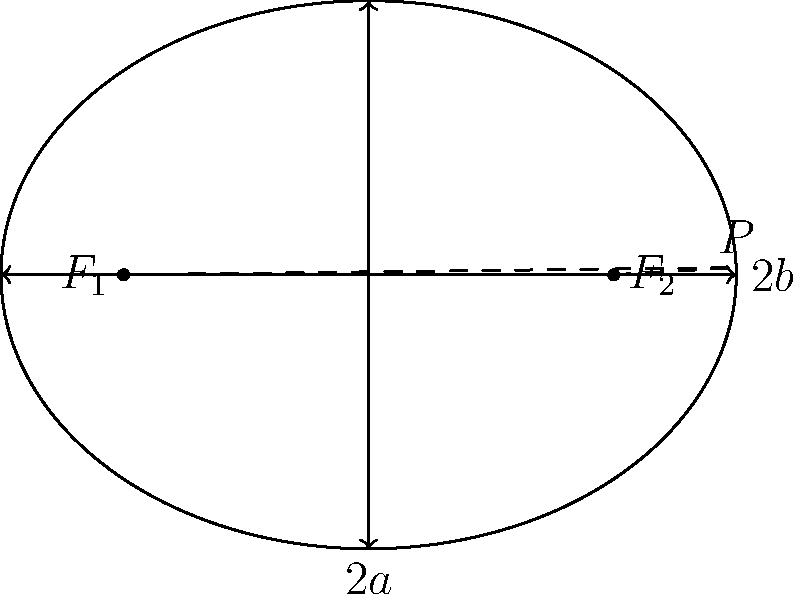Given an ellipse with focal points $F_1$ and $F_2$, and a point $P$ on the ellipse, prove that the sum of the distances from $P$ to the two focal points is constant and equal to the major axis length. How does this property relate to the eccentricity of the ellipse, and what implications does it have for potential applications in fields such as optics or satellite orbits? 1. Definition of an ellipse: The set of points $P$ such that $PF_1 + PF_2 = 2a$, where $2a$ is the length of the major axis.

2. Proof:
   a. Let $c$ be the distance from the center to each focus.
   b. The equation of the ellipse in Cartesian coordinates is:
      $$\frac{x^2}{a^2} + \frac{y^2}{b^2} = 1$$
      where $b^2 = a^2 - c^2$

3. For any point $P(x,y)$ on the ellipse:
   $$PF_1 + PF_2 = \sqrt{(x+c)^2 + y^2} + \sqrt{(x-c)^2 + y^2}$$

4. Using the algebraic properties of the ellipse equation and the distance formula, we can prove that this sum always equals $2a$.

5. Eccentricity ($e$) relation:
   $$e = \frac{c}{a} = \sqrt{1 - \frac{b^2}{a^2}}$$

6. Implications:
   a. Optics: Elliptical mirrors focus light from one focal point to the other.
   b. Satellite orbits: Planets follow elliptical orbits with the sun at one focus (Kepler's First Law).
   c. Optimization: Minimum total distance to two fixed points.

7. The constant sum property allows for efficient numerical algorithms in these applications, crucial for high-precision calculations in AI and computational geometry.
Answer: $PF_1 + PF_2 = 2a$; $e = \frac{c}{a}$ 